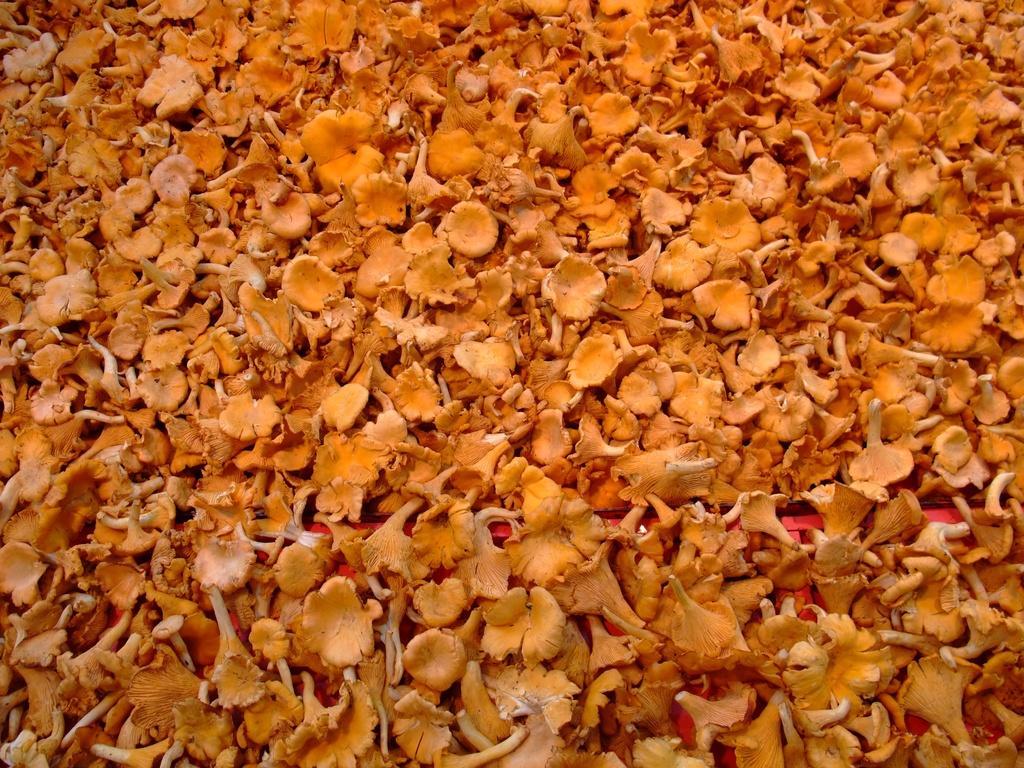How would you summarize this image in a sentence or two? In this image there are a group of flowers which are orange in color. 